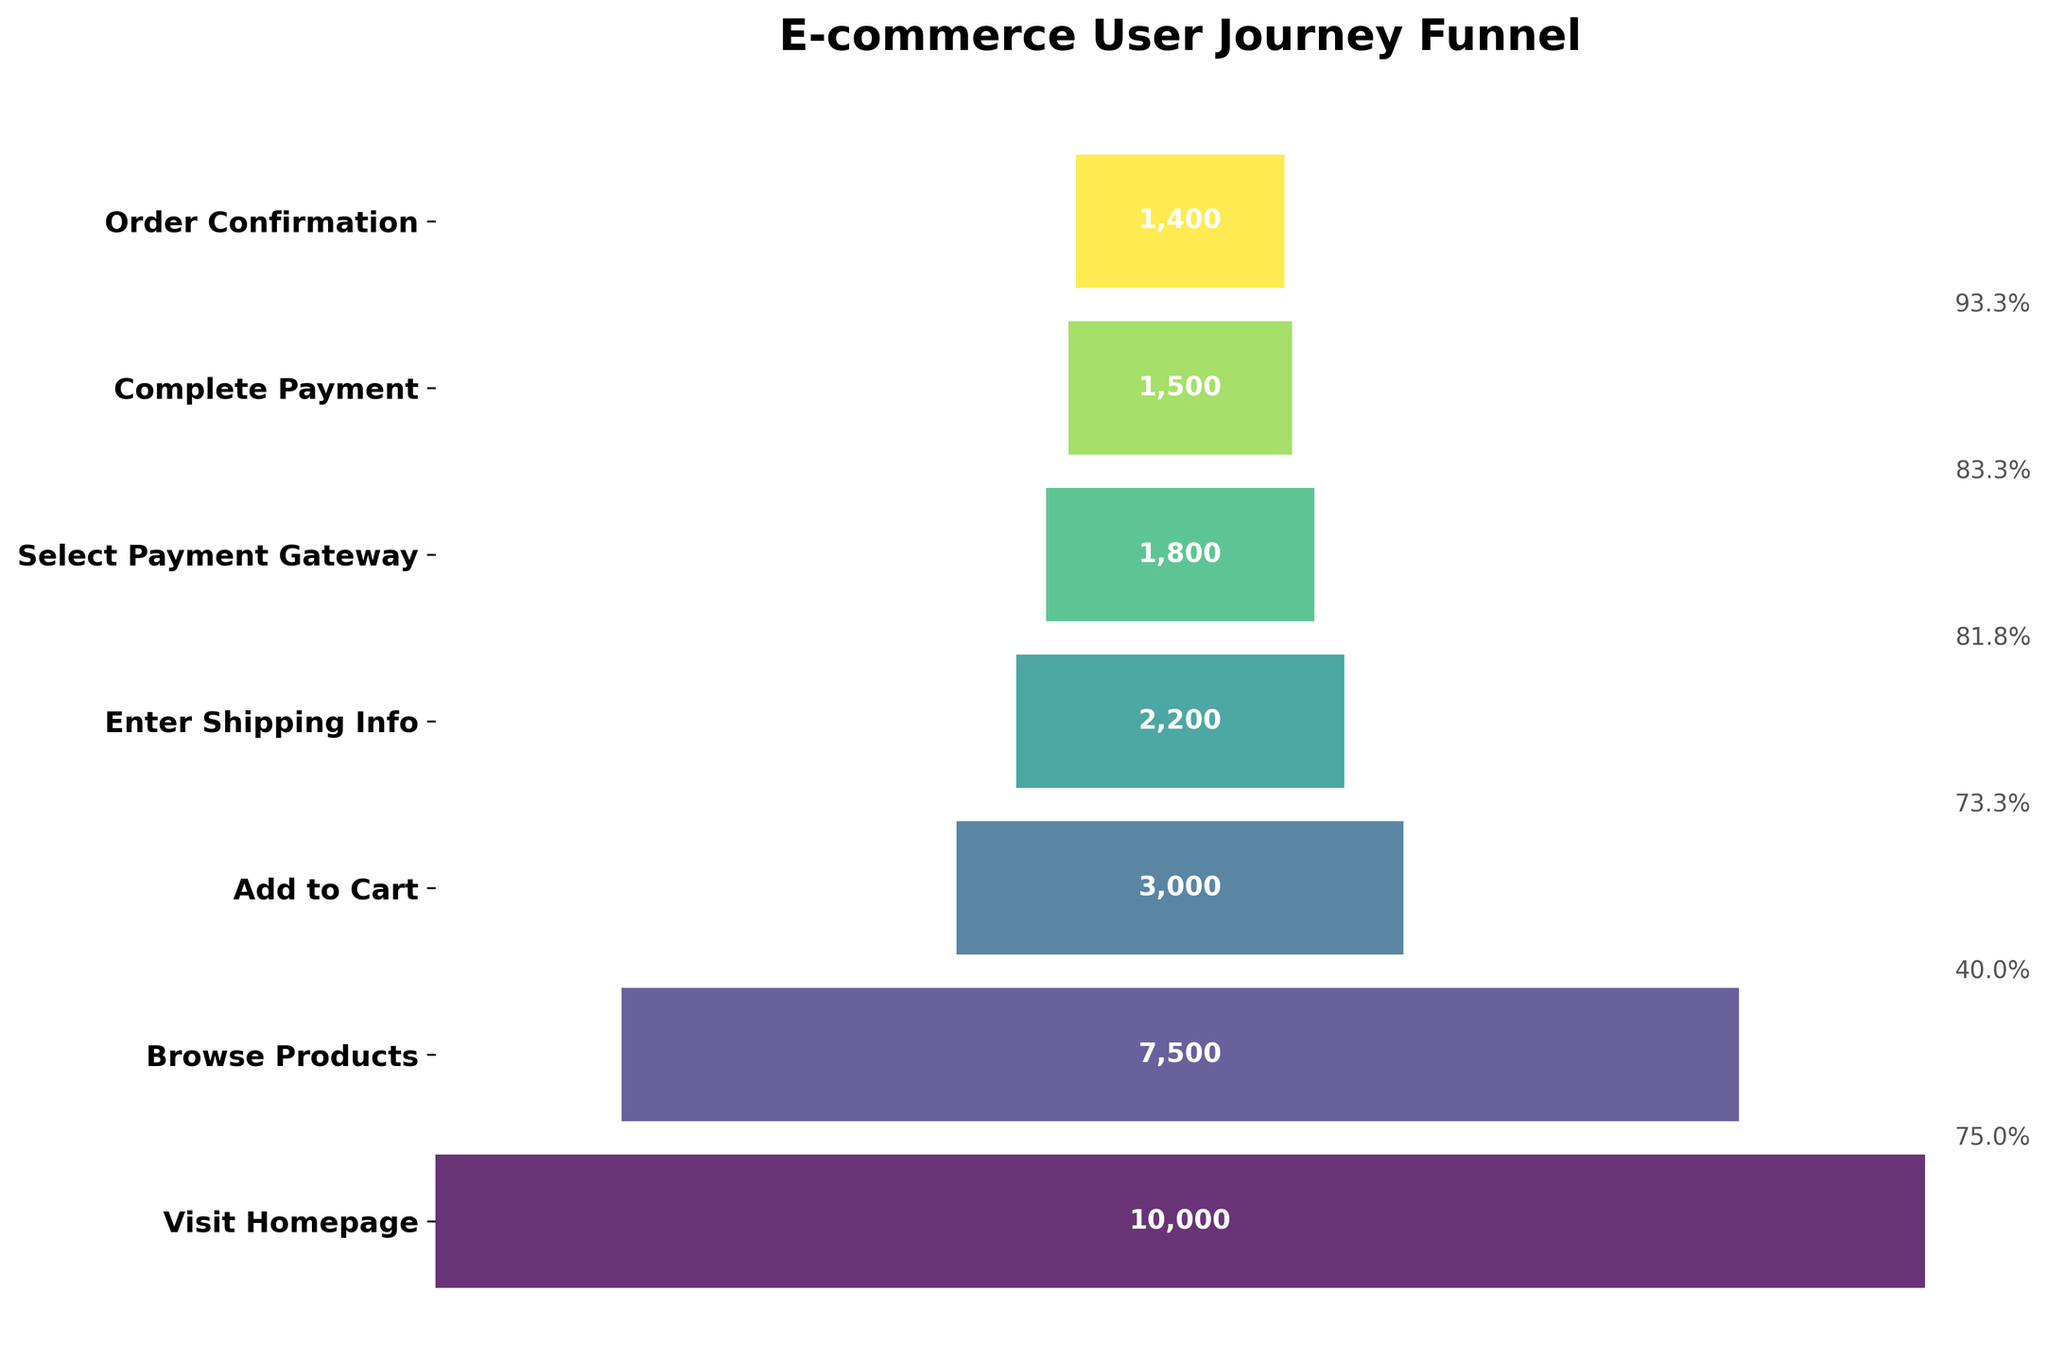What is the title of the funnel chart? The title of the chart is displayed at the top of the figure and describes the content of the chart. The title helps viewers understand the main topic being visualized.
Answer: E-commerce User Journey Funnel How many stages are there in the user journey? The number of stages can be determined by counting the distinct labels on the y-axis, which represent each stage of the user journey.
Answer: 7 Which stage has the highest number of users? The highest number of users corresponds to the widest bar segment at the top of the funnel chart, representing the starting point of the user journey.
Answer: Visit Homepage What percentage of users move from 'Add to Cart' to 'Enter Shipping Info'? To find the percentage, divide the number of users at 'Enter Shipping Info' by the number of users at 'Add to Cart'. Multiply the result by 100 to get the percentage. (2200 / 3000) * 100 = 73.3%
Answer: 73.3% What is the difference in the number of users between 'Select Payment Gateway' and 'Complete Payment'? The difference is found by subtracting the number of users at 'Complete Payment' from the number of users at 'Select Payment Gateway.' 1800 - 1500 = 300
Answer: 300 What percentage of users complete the payment after visiting the homepage? To find the percentage, divide the number of users at 'Complete Payment' by the number of users at 'Visit Homepage' and multiply by 100. (1500 / 10000) * 100 = 15%
Answer: 15% Which stage has the lowest user drop-off rate? To find this, compare the percentage drop-off between each consecutive stage. The stage with the smallest percentage decrease has the lowest drop-off rate. The transition with the smallest percentage decrease from the visual estimate is between 'Select Payment Gateway' and 'Complete Payment'.
Answer: Select Payment Gateway to Complete Payment How many users enter shipping information? The corresponding bar segment for 'Enter Shipping Info' has a number label that indicates how many users are in that stage of the user journey.
Answer: 2200 